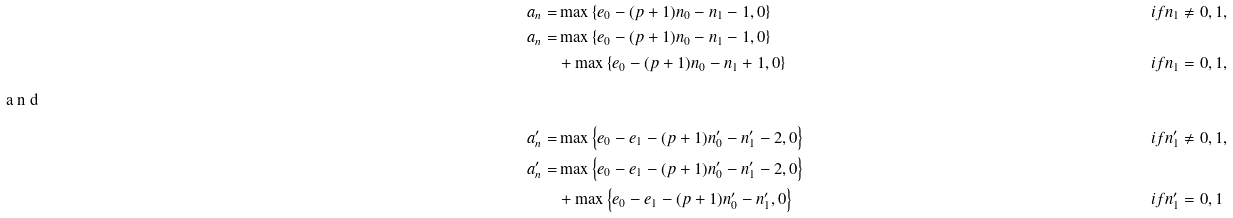<formula> <loc_0><loc_0><loc_500><loc_500>a _ { n } = & \max \left \{ e _ { 0 } - ( p + 1 ) n _ { 0 } - n _ { 1 } - 1 , 0 \right \} & & i f n _ { 1 } \neq 0 , 1 , \\ a _ { n } = & \max \left \{ e _ { 0 } - ( p + 1 ) n _ { 0 } - n _ { 1 } - 1 , 0 \right \} & & \\ & + \max \left \{ e _ { 0 } - ( p + 1 ) n _ { 0 } - n _ { 1 } + 1 , 0 \right \} & & i f n _ { 1 } = 0 , 1 , \\ \intertext { a n d } a _ { n } ^ { \prime } = & \max \left \{ e _ { 0 } - e _ { 1 } - ( p + 1 ) n _ { 0 } ^ { \prime } - n _ { 1 } ^ { \prime } - 2 , 0 \right \} & & i f n _ { 1 } ^ { \prime } \neq 0 , 1 , \\ a _ { n } ^ { \prime } = & \max \left \{ e _ { 0 } - e _ { 1 } - ( p + 1 ) n _ { 0 } ^ { \prime } - n _ { 1 } ^ { \prime } - 2 , 0 \right \} & & \\ & + \max \left \{ e _ { 0 } - e _ { 1 } - ( p + 1 ) n _ { 0 } ^ { \prime } - n _ { 1 } ^ { \prime } , 0 \right \} & & i f n _ { 1 } ^ { \prime } = 0 , 1</formula> 